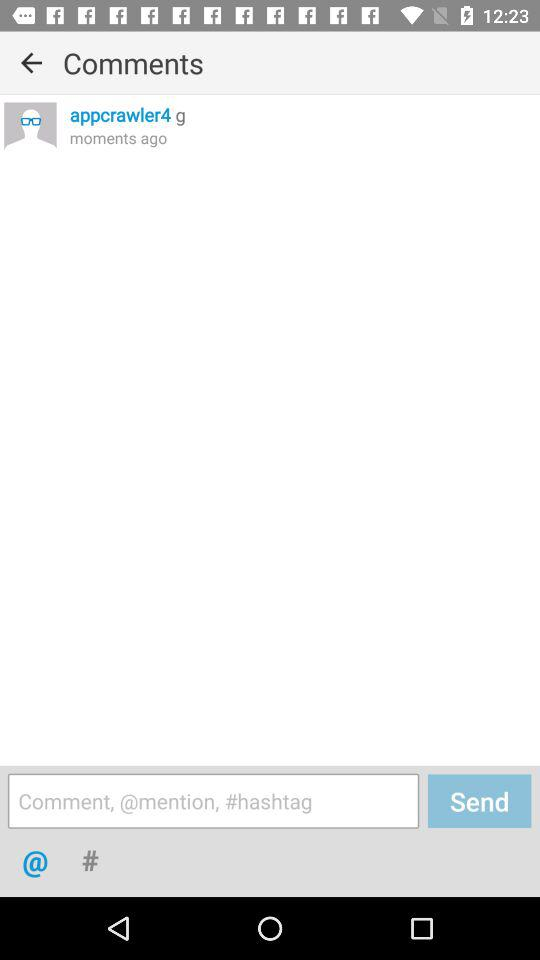What is the username? The username is "appcrawler4". 